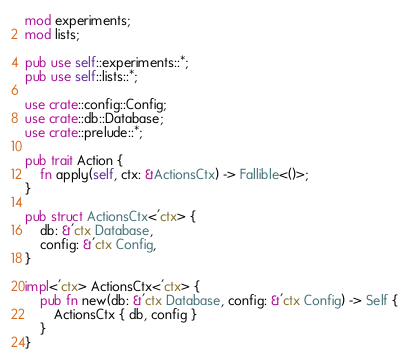<code> <loc_0><loc_0><loc_500><loc_500><_Rust_>mod experiments;
mod lists;

pub use self::experiments::*;
pub use self::lists::*;

use crate::config::Config;
use crate::db::Database;
use crate::prelude::*;

pub trait Action {
    fn apply(self, ctx: &ActionsCtx) -> Fallible<()>;
}

pub struct ActionsCtx<'ctx> {
    db: &'ctx Database,
    config: &'ctx Config,
}

impl<'ctx> ActionsCtx<'ctx> {
    pub fn new(db: &'ctx Database, config: &'ctx Config) -> Self {
        ActionsCtx { db, config }
    }
}
</code> 